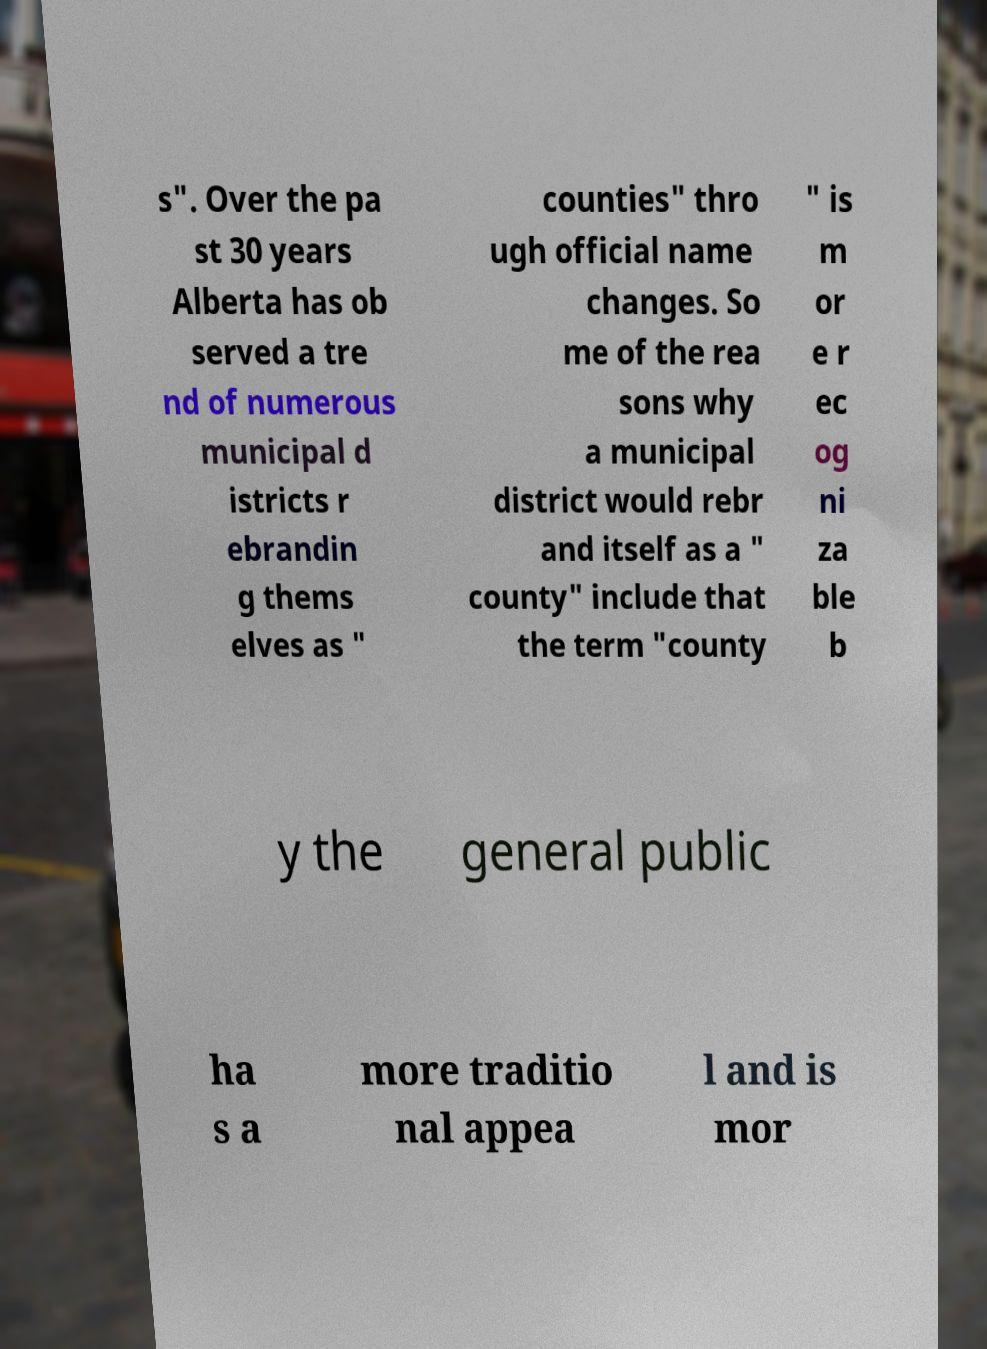I need the written content from this picture converted into text. Can you do that? s". Over the pa st 30 years Alberta has ob served a tre nd of numerous municipal d istricts r ebrandin g thems elves as " counties" thro ugh official name changes. So me of the rea sons why a municipal district would rebr and itself as a " county" include that the term "county " is m or e r ec og ni za ble b y the general public ha s a more traditio nal appea l and is mor 